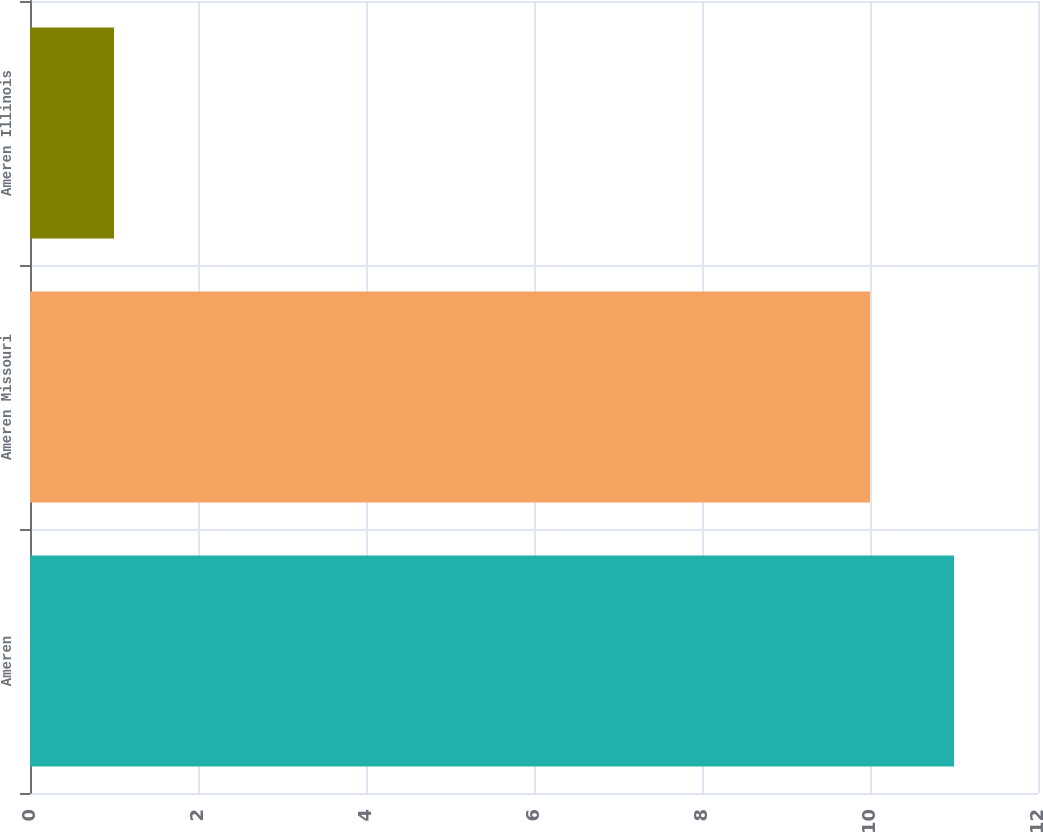<chart> <loc_0><loc_0><loc_500><loc_500><bar_chart><fcel>Ameren<fcel>Ameren Missouri<fcel>Ameren Illinois<nl><fcel>11<fcel>10<fcel>1<nl></chart> 